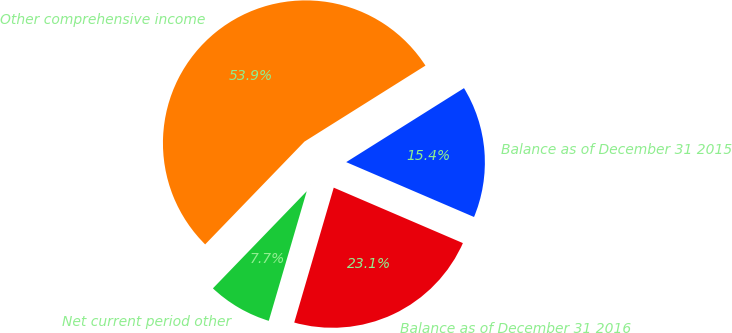Convert chart to OTSL. <chart><loc_0><loc_0><loc_500><loc_500><pie_chart><fcel>Balance as of December 31 2015<fcel>Other comprehensive income<fcel>Net current period other<fcel>Balance as of December 31 2016<nl><fcel>15.38%<fcel>53.85%<fcel>7.69%<fcel>23.08%<nl></chart> 